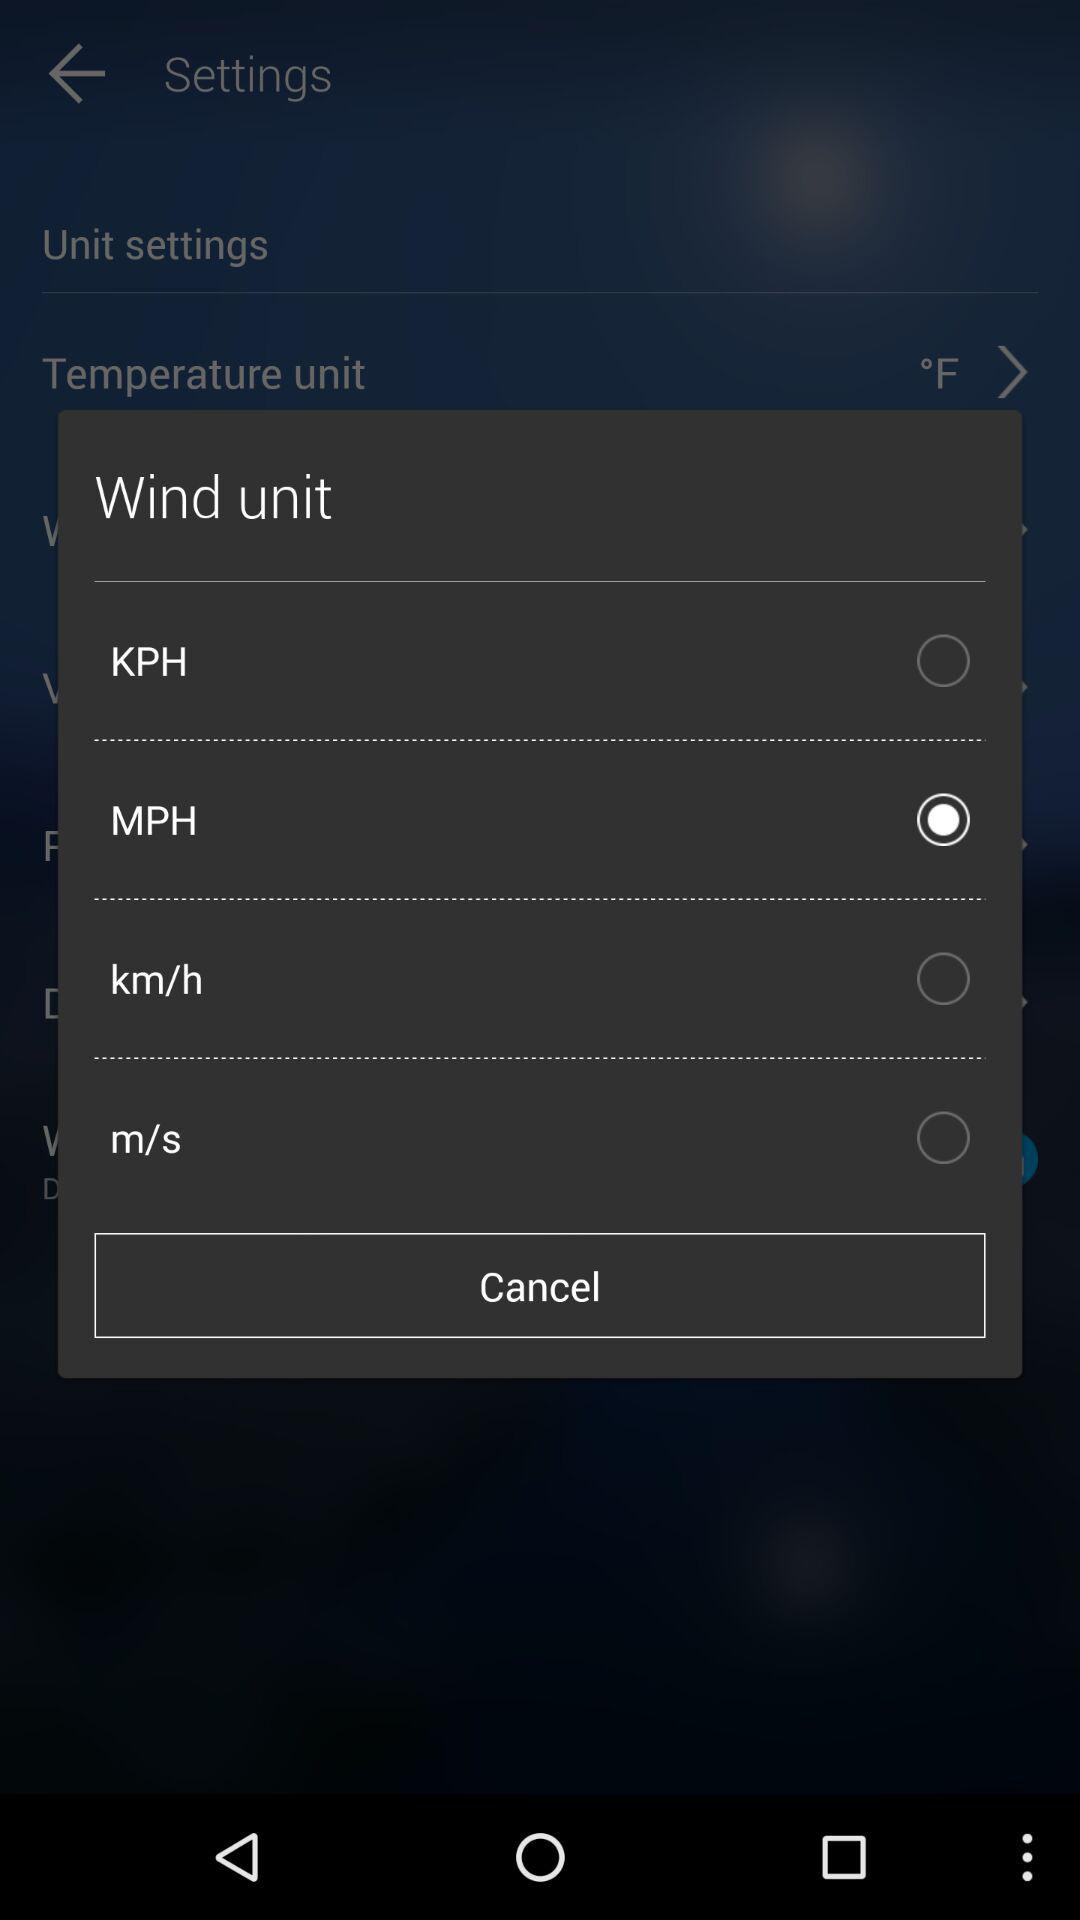How many units are available for the wind speed?
Answer the question using a single word or phrase. 4 